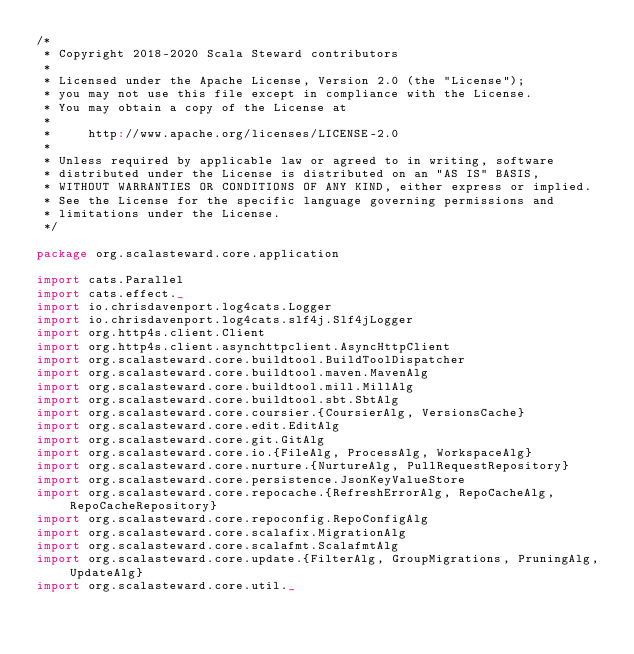Convert code to text. <code><loc_0><loc_0><loc_500><loc_500><_Scala_>/*
 * Copyright 2018-2020 Scala Steward contributors
 *
 * Licensed under the Apache License, Version 2.0 (the "License");
 * you may not use this file except in compliance with the License.
 * You may obtain a copy of the License at
 *
 *     http://www.apache.org/licenses/LICENSE-2.0
 *
 * Unless required by applicable law or agreed to in writing, software
 * distributed under the License is distributed on an "AS IS" BASIS,
 * WITHOUT WARRANTIES OR CONDITIONS OF ANY KIND, either express or implied.
 * See the License for the specific language governing permissions and
 * limitations under the License.
 */

package org.scalasteward.core.application

import cats.Parallel
import cats.effect._
import io.chrisdavenport.log4cats.Logger
import io.chrisdavenport.log4cats.slf4j.Slf4jLogger
import org.http4s.client.Client
import org.http4s.client.asynchttpclient.AsyncHttpClient
import org.scalasteward.core.buildtool.BuildToolDispatcher
import org.scalasteward.core.buildtool.maven.MavenAlg
import org.scalasteward.core.buildtool.mill.MillAlg
import org.scalasteward.core.buildtool.sbt.SbtAlg
import org.scalasteward.core.coursier.{CoursierAlg, VersionsCache}
import org.scalasteward.core.edit.EditAlg
import org.scalasteward.core.git.GitAlg
import org.scalasteward.core.io.{FileAlg, ProcessAlg, WorkspaceAlg}
import org.scalasteward.core.nurture.{NurtureAlg, PullRequestRepository}
import org.scalasteward.core.persistence.JsonKeyValueStore
import org.scalasteward.core.repocache.{RefreshErrorAlg, RepoCacheAlg, RepoCacheRepository}
import org.scalasteward.core.repoconfig.RepoConfigAlg
import org.scalasteward.core.scalafix.MigrationAlg
import org.scalasteward.core.scalafmt.ScalafmtAlg
import org.scalasteward.core.update.{FilterAlg, GroupMigrations, PruningAlg, UpdateAlg}
import org.scalasteward.core.util._</code> 